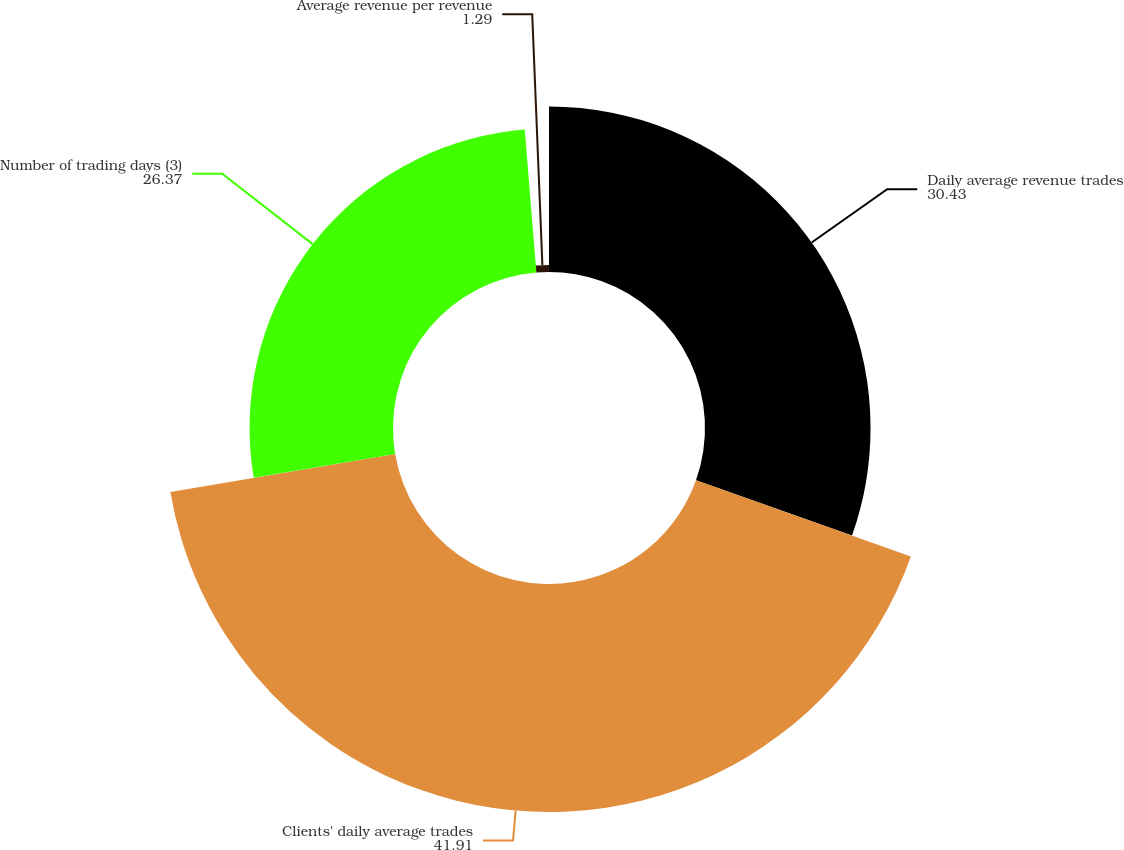Convert chart. <chart><loc_0><loc_0><loc_500><loc_500><pie_chart><fcel>Daily average revenue trades<fcel>Clients' daily average trades<fcel>Number of trading days (3)<fcel>Average revenue per revenue<nl><fcel>30.43%<fcel>41.91%<fcel>26.37%<fcel>1.29%<nl></chart> 